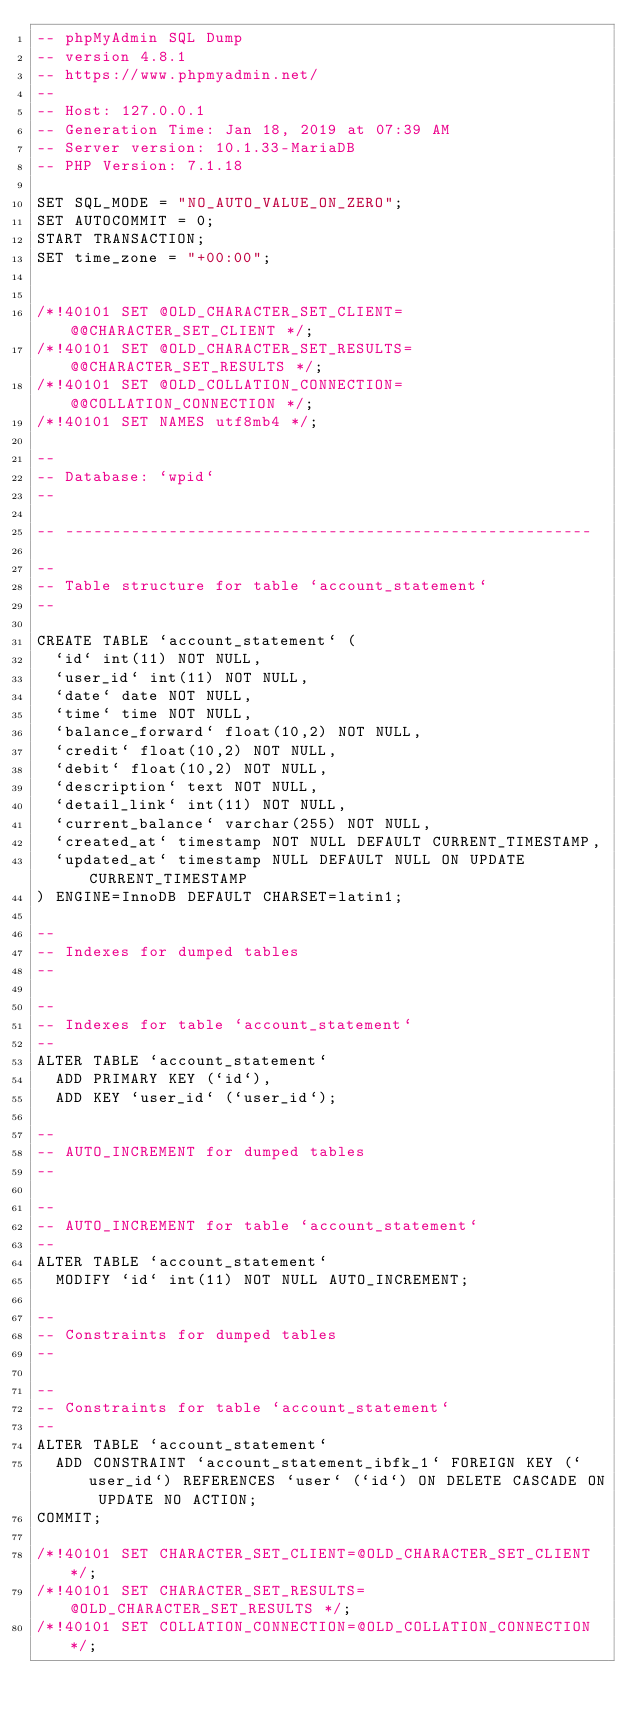<code> <loc_0><loc_0><loc_500><loc_500><_SQL_>-- phpMyAdmin SQL Dump
-- version 4.8.1
-- https://www.phpmyadmin.net/
--
-- Host: 127.0.0.1
-- Generation Time: Jan 18, 2019 at 07:39 AM
-- Server version: 10.1.33-MariaDB
-- PHP Version: 7.1.18

SET SQL_MODE = "NO_AUTO_VALUE_ON_ZERO";
SET AUTOCOMMIT = 0;
START TRANSACTION;
SET time_zone = "+00:00";


/*!40101 SET @OLD_CHARACTER_SET_CLIENT=@@CHARACTER_SET_CLIENT */;
/*!40101 SET @OLD_CHARACTER_SET_RESULTS=@@CHARACTER_SET_RESULTS */;
/*!40101 SET @OLD_COLLATION_CONNECTION=@@COLLATION_CONNECTION */;
/*!40101 SET NAMES utf8mb4 */;

--
-- Database: `wpid`
--

-- --------------------------------------------------------

--
-- Table structure for table `account_statement`
--

CREATE TABLE `account_statement` (
  `id` int(11) NOT NULL,
  `user_id` int(11) NOT NULL,
  `date` date NOT NULL,
  `time` time NOT NULL,
  `balance_forward` float(10,2) NOT NULL,
  `credit` float(10,2) NOT NULL,
  `debit` float(10,2) NOT NULL,
  `description` text NOT NULL,
  `detail_link` int(11) NOT NULL,
  `current_balance` varchar(255) NOT NULL,
  `created_at` timestamp NOT NULL DEFAULT CURRENT_TIMESTAMP,
  `updated_at` timestamp NULL DEFAULT NULL ON UPDATE CURRENT_TIMESTAMP
) ENGINE=InnoDB DEFAULT CHARSET=latin1;

--
-- Indexes for dumped tables
--

--
-- Indexes for table `account_statement`
--
ALTER TABLE `account_statement`
  ADD PRIMARY KEY (`id`),
  ADD KEY `user_id` (`user_id`);

--
-- AUTO_INCREMENT for dumped tables
--

--
-- AUTO_INCREMENT for table `account_statement`
--
ALTER TABLE `account_statement`
  MODIFY `id` int(11) NOT NULL AUTO_INCREMENT;

--
-- Constraints for dumped tables
--

--
-- Constraints for table `account_statement`
--
ALTER TABLE `account_statement`
  ADD CONSTRAINT `account_statement_ibfk_1` FOREIGN KEY (`user_id`) REFERENCES `user` (`id`) ON DELETE CASCADE ON UPDATE NO ACTION;
COMMIT;

/*!40101 SET CHARACTER_SET_CLIENT=@OLD_CHARACTER_SET_CLIENT */;
/*!40101 SET CHARACTER_SET_RESULTS=@OLD_CHARACTER_SET_RESULTS */;
/*!40101 SET COLLATION_CONNECTION=@OLD_COLLATION_CONNECTION */;
</code> 